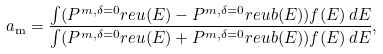Convert formula to latex. <formula><loc_0><loc_0><loc_500><loc_500>a _ { \text {m} } = \frac { \int ( P ^ { m , \delta = 0 } _ { \ } r e u ( E ) - P ^ { m , \delta = 0 } _ { \ } r e u b ( E ) ) f ( E ) \, d E } { \int ( P ^ { m , \delta = 0 } _ { \ } r e u ( E ) + P ^ { m , \delta = 0 } _ { \ } r e u b ( E ) ) f ( E ) \, d E } ,</formula> 